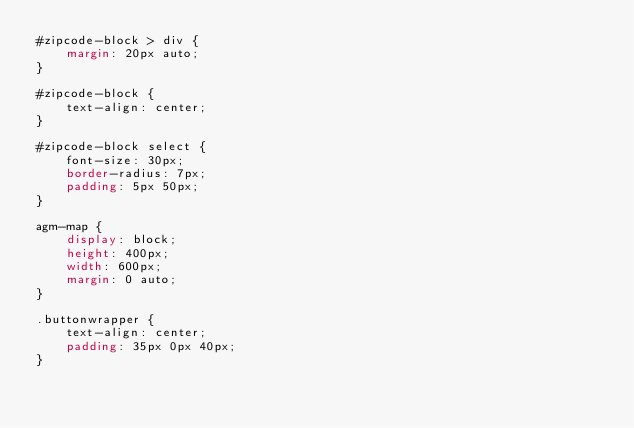Convert code to text. <code><loc_0><loc_0><loc_500><loc_500><_CSS_>#zipcode-block > div {
	margin: 20px auto;
}

#zipcode-block {
	text-align: center;
}

#zipcode-block select {
	font-size: 30px;
	border-radius: 7px;
	padding: 5px 50px;
}

agm-map {
	display: block;
	height: 400px;
	width: 600px;
	margin: 0 auto;
}

.buttonwrapper {
	text-align: center;
	padding: 35px 0px 40px;
}</code> 